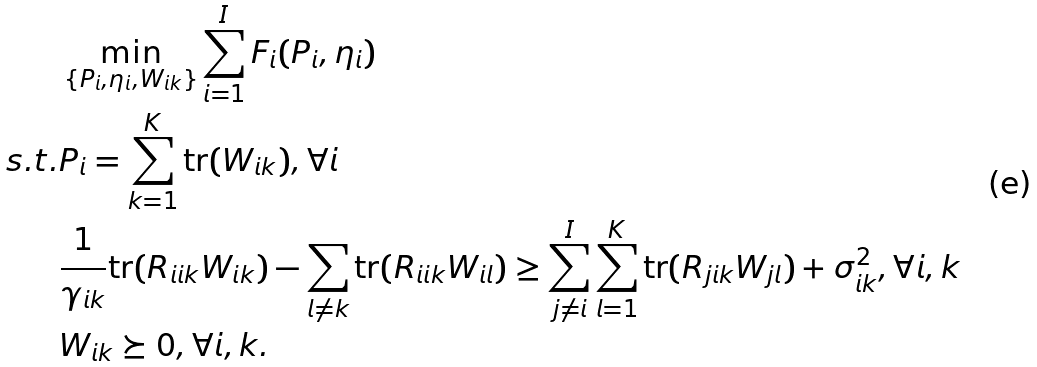Convert formula to latex. <formula><loc_0><loc_0><loc_500><loc_500>& \min _ { \{ P _ { i } , \eta _ { i } , W _ { i k } \} } \sum _ { i = 1 } ^ { I } F _ { i } ( P _ { i } , \eta _ { i } ) \\ s . t . & P _ { i } = \sum _ { k = 1 } ^ { K } \text {tr} ( W _ { i k } ) , \forall i \\ & \frac { 1 } { \gamma _ { i k } } \text {tr} ( R _ { i i k } W _ { i k } ) - \sum _ { l \neq k } \text {tr} ( R _ { i i k } W _ { i l } ) \geq \sum _ { j \neq i } ^ { I } \sum _ { l = 1 } ^ { K } \text {tr} ( R _ { j i k } W _ { j l } ) + \sigma _ { i k } ^ { 2 } , \forall i , k \\ & W _ { i k } \succeq 0 , \forall i , k .</formula> 